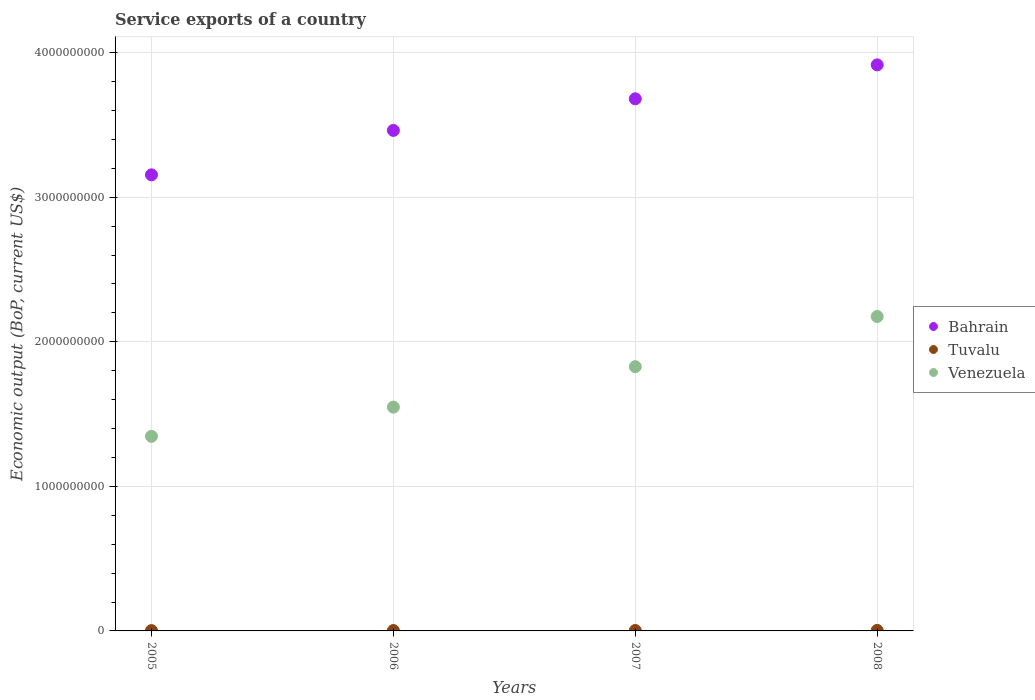What is the service exports in Tuvalu in 2005?
Your answer should be compact. 2.29e+06. Across all years, what is the maximum service exports in Bahrain?
Give a very brief answer. 3.92e+09. Across all years, what is the minimum service exports in Bahrain?
Give a very brief answer. 3.15e+09. In which year was the service exports in Venezuela maximum?
Offer a very short reply. 2008. What is the total service exports in Venezuela in the graph?
Ensure brevity in your answer.  6.90e+09. What is the difference between the service exports in Venezuela in 2005 and that in 2008?
Your answer should be very brief. -8.29e+08. What is the difference between the service exports in Tuvalu in 2006 and the service exports in Venezuela in 2005?
Make the answer very short. -1.34e+09. What is the average service exports in Bahrain per year?
Your answer should be compact. 3.55e+09. In the year 2005, what is the difference between the service exports in Tuvalu and service exports in Venezuela?
Your response must be concise. -1.34e+09. What is the ratio of the service exports in Venezuela in 2005 to that in 2008?
Provide a succinct answer. 0.62. Is the service exports in Bahrain in 2005 less than that in 2008?
Offer a very short reply. Yes. What is the difference between the highest and the second highest service exports in Bahrain?
Ensure brevity in your answer.  2.35e+08. What is the difference between the highest and the lowest service exports in Bahrain?
Keep it short and to the point. 7.61e+08. Is it the case that in every year, the sum of the service exports in Bahrain and service exports in Tuvalu  is greater than the service exports in Venezuela?
Your answer should be compact. Yes. Is the service exports in Bahrain strictly greater than the service exports in Venezuela over the years?
Keep it short and to the point. Yes. How many dotlines are there?
Make the answer very short. 3. How many years are there in the graph?
Give a very brief answer. 4. Where does the legend appear in the graph?
Your answer should be very brief. Center right. How many legend labels are there?
Provide a short and direct response. 3. What is the title of the graph?
Keep it short and to the point. Service exports of a country. Does "Arab World" appear as one of the legend labels in the graph?
Make the answer very short. No. What is the label or title of the Y-axis?
Provide a succinct answer. Economic output (BoP, current US$). What is the Economic output (BoP, current US$) in Bahrain in 2005?
Give a very brief answer. 3.15e+09. What is the Economic output (BoP, current US$) in Tuvalu in 2005?
Your response must be concise. 2.29e+06. What is the Economic output (BoP, current US$) of Venezuela in 2005?
Offer a very short reply. 1.35e+09. What is the Economic output (BoP, current US$) in Bahrain in 2006?
Ensure brevity in your answer.  3.46e+09. What is the Economic output (BoP, current US$) of Tuvalu in 2006?
Offer a terse response. 2.60e+06. What is the Economic output (BoP, current US$) of Venezuela in 2006?
Your response must be concise. 1.55e+09. What is the Economic output (BoP, current US$) in Bahrain in 2007?
Provide a short and direct response. 3.68e+09. What is the Economic output (BoP, current US$) in Tuvalu in 2007?
Provide a succinct answer. 2.87e+06. What is the Economic output (BoP, current US$) of Venezuela in 2007?
Give a very brief answer. 1.83e+09. What is the Economic output (BoP, current US$) in Bahrain in 2008?
Keep it short and to the point. 3.92e+09. What is the Economic output (BoP, current US$) in Tuvalu in 2008?
Ensure brevity in your answer.  3.52e+06. What is the Economic output (BoP, current US$) in Venezuela in 2008?
Offer a terse response. 2.18e+09. Across all years, what is the maximum Economic output (BoP, current US$) of Bahrain?
Provide a short and direct response. 3.92e+09. Across all years, what is the maximum Economic output (BoP, current US$) of Tuvalu?
Make the answer very short. 3.52e+06. Across all years, what is the maximum Economic output (BoP, current US$) in Venezuela?
Offer a terse response. 2.18e+09. Across all years, what is the minimum Economic output (BoP, current US$) of Bahrain?
Your response must be concise. 3.15e+09. Across all years, what is the minimum Economic output (BoP, current US$) of Tuvalu?
Offer a very short reply. 2.29e+06. Across all years, what is the minimum Economic output (BoP, current US$) in Venezuela?
Make the answer very short. 1.35e+09. What is the total Economic output (BoP, current US$) in Bahrain in the graph?
Offer a terse response. 1.42e+1. What is the total Economic output (BoP, current US$) of Tuvalu in the graph?
Ensure brevity in your answer.  1.13e+07. What is the total Economic output (BoP, current US$) of Venezuela in the graph?
Ensure brevity in your answer.  6.90e+09. What is the difference between the Economic output (BoP, current US$) of Bahrain in 2005 and that in 2006?
Ensure brevity in your answer.  -3.07e+08. What is the difference between the Economic output (BoP, current US$) in Tuvalu in 2005 and that in 2006?
Ensure brevity in your answer.  -3.07e+05. What is the difference between the Economic output (BoP, current US$) in Venezuela in 2005 and that in 2006?
Your answer should be very brief. -2.02e+08. What is the difference between the Economic output (BoP, current US$) of Bahrain in 2005 and that in 2007?
Your answer should be very brief. -5.26e+08. What is the difference between the Economic output (BoP, current US$) in Tuvalu in 2005 and that in 2007?
Your answer should be compact. -5.75e+05. What is the difference between the Economic output (BoP, current US$) of Venezuela in 2005 and that in 2007?
Make the answer very short. -4.82e+08. What is the difference between the Economic output (BoP, current US$) of Bahrain in 2005 and that in 2008?
Give a very brief answer. -7.61e+08. What is the difference between the Economic output (BoP, current US$) of Tuvalu in 2005 and that in 2008?
Your response must be concise. -1.23e+06. What is the difference between the Economic output (BoP, current US$) of Venezuela in 2005 and that in 2008?
Provide a succinct answer. -8.29e+08. What is the difference between the Economic output (BoP, current US$) of Bahrain in 2006 and that in 2007?
Keep it short and to the point. -2.19e+08. What is the difference between the Economic output (BoP, current US$) of Tuvalu in 2006 and that in 2007?
Give a very brief answer. -2.68e+05. What is the difference between the Economic output (BoP, current US$) in Venezuela in 2006 and that in 2007?
Ensure brevity in your answer.  -2.80e+08. What is the difference between the Economic output (BoP, current US$) in Bahrain in 2006 and that in 2008?
Your response must be concise. -4.53e+08. What is the difference between the Economic output (BoP, current US$) of Tuvalu in 2006 and that in 2008?
Make the answer very short. -9.21e+05. What is the difference between the Economic output (BoP, current US$) in Venezuela in 2006 and that in 2008?
Ensure brevity in your answer.  -6.27e+08. What is the difference between the Economic output (BoP, current US$) of Bahrain in 2007 and that in 2008?
Provide a short and direct response. -2.35e+08. What is the difference between the Economic output (BoP, current US$) of Tuvalu in 2007 and that in 2008?
Provide a succinct answer. -6.52e+05. What is the difference between the Economic output (BoP, current US$) in Venezuela in 2007 and that in 2008?
Provide a short and direct response. -3.47e+08. What is the difference between the Economic output (BoP, current US$) in Bahrain in 2005 and the Economic output (BoP, current US$) in Tuvalu in 2006?
Provide a short and direct response. 3.15e+09. What is the difference between the Economic output (BoP, current US$) of Bahrain in 2005 and the Economic output (BoP, current US$) of Venezuela in 2006?
Offer a terse response. 1.61e+09. What is the difference between the Economic output (BoP, current US$) in Tuvalu in 2005 and the Economic output (BoP, current US$) in Venezuela in 2006?
Your answer should be compact. -1.55e+09. What is the difference between the Economic output (BoP, current US$) of Bahrain in 2005 and the Economic output (BoP, current US$) of Tuvalu in 2007?
Your answer should be compact. 3.15e+09. What is the difference between the Economic output (BoP, current US$) of Bahrain in 2005 and the Economic output (BoP, current US$) of Venezuela in 2007?
Provide a short and direct response. 1.33e+09. What is the difference between the Economic output (BoP, current US$) of Tuvalu in 2005 and the Economic output (BoP, current US$) of Venezuela in 2007?
Your response must be concise. -1.83e+09. What is the difference between the Economic output (BoP, current US$) in Bahrain in 2005 and the Economic output (BoP, current US$) in Tuvalu in 2008?
Your answer should be compact. 3.15e+09. What is the difference between the Economic output (BoP, current US$) of Bahrain in 2005 and the Economic output (BoP, current US$) of Venezuela in 2008?
Provide a succinct answer. 9.80e+08. What is the difference between the Economic output (BoP, current US$) in Tuvalu in 2005 and the Economic output (BoP, current US$) in Venezuela in 2008?
Offer a terse response. -2.17e+09. What is the difference between the Economic output (BoP, current US$) of Bahrain in 2006 and the Economic output (BoP, current US$) of Tuvalu in 2007?
Offer a terse response. 3.46e+09. What is the difference between the Economic output (BoP, current US$) of Bahrain in 2006 and the Economic output (BoP, current US$) of Venezuela in 2007?
Your response must be concise. 1.63e+09. What is the difference between the Economic output (BoP, current US$) of Tuvalu in 2006 and the Economic output (BoP, current US$) of Venezuela in 2007?
Make the answer very short. -1.83e+09. What is the difference between the Economic output (BoP, current US$) of Bahrain in 2006 and the Economic output (BoP, current US$) of Tuvalu in 2008?
Provide a short and direct response. 3.46e+09. What is the difference between the Economic output (BoP, current US$) of Bahrain in 2006 and the Economic output (BoP, current US$) of Venezuela in 2008?
Make the answer very short. 1.29e+09. What is the difference between the Economic output (BoP, current US$) in Tuvalu in 2006 and the Economic output (BoP, current US$) in Venezuela in 2008?
Provide a succinct answer. -2.17e+09. What is the difference between the Economic output (BoP, current US$) of Bahrain in 2007 and the Economic output (BoP, current US$) of Tuvalu in 2008?
Your response must be concise. 3.68e+09. What is the difference between the Economic output (BoP, current US$) in Bahrain in 2007 and the Economic output (BoP, current US$) in Venezuela in 2008?
Your response must be concise. 1.51e+09. What is the difference between the Economic output (BoP, current US$) of Tuvalu in 2007 and the Economic output (BoP, current US$) of Venezuela in 2008?
Offer a very short reply. -2.17e+09. What is the average Economic output (BoP, current US$) in Bahrain per year?
Provide a short and direct response. 3.55e+09. What is the average Economic output (BoP, current US$) of Tuvalu per year?
Your answer should be very brief. 2.82e+06. What is the average Economic output (BoP, current US$) of Venezuela per year?
Offer a very short reply. 1.72e+09. In the year 2005, what is the difference between the Economic output (BoP, current US$) of Bahrain and Economic output (BoP, current US$) of Tuvalu?
Provide a short and direct response. 3.15e+09. In the year 2005, what is the difference between the Economic output (BoP, current US$) of Bahrain and Economic output (BoP, current US$) of Venezuela?
Make the answer very short. 1.81e+09. In the year 2005, what is the difference between the Economic output (BoP, current US$) in Tuvalu and Economic output (BoP, current US$) in Venezuela?
Offer a very short reply. -1.34e+09. In the year 2006, what is the difference between the Economic output (BoP, current US$) of Bahrain and Economic output (BoP, current US$) of Tuvalu?
Keep it short and to the point. 3.46e+09. In the year 2006, what is the difference between the Economic output (BoP, current US$) of Bahrain and Economic output (BoP, current US$) of Venezuela?
Your response must be concise. 1.91e+09. In the year 2006, what is the difference between the Economic output (BoP, current US$) of Tuvalu and Economic output (BoP, current US$) of Venezuela?
Your answer should be compact. -1.55e+09. In the year 2007, what is the difference between the Economic output (BoP, current US$) of Bahrain and Economic output (BoP, current US$) of Tuvalu?
Keep it short and to the point. 3.68e+09. In the year 2007, what is the difference between the Economic output (BoP, current US$) in Bahrain and Economic output (BoP, current US$) in Venezuela?
Make the answer very short. 1.85e+09. In the year 2007, what is the difference between the Economic output (BoP, current US$) of Tuvalu and Economic output (BoP, current US$) of Venezuela?
Offer a terse response. -1.83e+09. In the year 2008, what is the difference between the Economic output (BoP, current US$) of Bahrain and Economic output (BoP, current US$) of Tuvalu?
Provide a succinct answer. 3.91e+09. In the year 2008, what is the difference between the Economic output (BoP, current US$) of Bahrain and Economic output (BoP, current US$) of Venezuela?
Ensure brevity in your answer.  1.74e+09. In the year 2008, what is the difference between the Economic output (BoP, current US$) in Tuvalu and Economic output (BoP, current US$) in Venezuela?
Your response must be concise. -2.17e+09. What is the ratio of the Economic output (BoP, current US$) of Bahrain in 2005 to that in 2006?
Provide a short and direct response. 0.91. What is the ratio of the Economic output (BoP, current US$) in Tuvalu in 2005 to that in 2006?
Give a very brief answer. 0.88. What is the ratio of the Economic output (BoP, current US$) of Venezuela in 2005 to that in 2006?
Offer a very short reply. 0.87. What is the ratio of the Economic output (BoP, current US$) of Tuvalu in 2005 to that in 2007?
Provide a short and direct response. 0.8. What is the ratio of the Economic output (BoP, current US$) of Venezuela in 2005 to that in 2007?
Provide a succinct answer. 0.74. What is the ratio of the Economic output (BoP, current US$) of Bahrain in 2005 to that in 2008?
Give a very brief answer. 0.81. What is the ratio of the Economic output (BoP, current US$) in Tuvalu in 2005 to that in 2008?
Ensure brevity in your answer.  0.65. What is the ratio of the Economic output (BoP, current US$) in Venezuela in 2005 to that in 2008?
Provide a short and direct response. 0.62. What is the ratio of the Economic output (BoP, current US$) in Bahrain in 2006 to that in 2007?
Your answer should be very brief. 0.94. What is the ratio of the Economic output (BoP, current US$) in Tuvalu in 2006 to that in 2007?
Make the answer very short. 0.91. What is the ratio of the Economic output (BoP, current US$) in Venezuela in 2006 to that in 2007?
Your answer should be very brief. 0.85. What is the ratio of the Economic output (BoP, current US$) of Bahrain in 2006 to that in 2008?
Offer a terse response. 0.88. What is the ratio of the Economic output (BoP, current US$) in Tuvalu in 2006 to that in 2008?
Your answer should be compact. 0.74. What is the ratio of the Economic output (BoP, current US$) of Venezuela in 2006 to that in 2008?
Make the answer very short. 0.71. What is the ratio of the Economic output (BoP, current US$) of Bahrain in 2007 to that in 2008?
Ensure brevity in your answer.  0.94. What is the ratio of the Economic output (BoP, current US$) of Tuvalu in 2007 to that in 2008?
Make the answer very short. 0.81. What is the ratio of the Economic output (BoP, current US$) in Venezuela in 2007 to that in 2008?
Your answer should be very brief. 0.84. What is the difference between the highest and the second highest Economic output (BoP, current US$) in Bahrain?
Provide a short and direct response. 2.35e+08. What is the difference between the highest and the second highest Economic output (BoP, current US$) of Tuvalu?
Your response must be concise. 6.52e+05. What is the difference between the highest and the second highest Economic output (BoP, current US$) in Venezuela?
Give a very brief answer. 3.47e+08. What is the difference between the highest and the lowest Economic output (BoP, current US$) in Bahrain?
Your answer should be compact. 7.61e+08. What is the difference between the highest and the lowest Economic output (BoP, current US$) of Tuvalu?
Keep it short and to the point. 1.23e+06. What is the difference between the highest and the lowest Economic output (BoP, current US$) of Venezuela?
Offer a very short reply. 8.29e+08. 